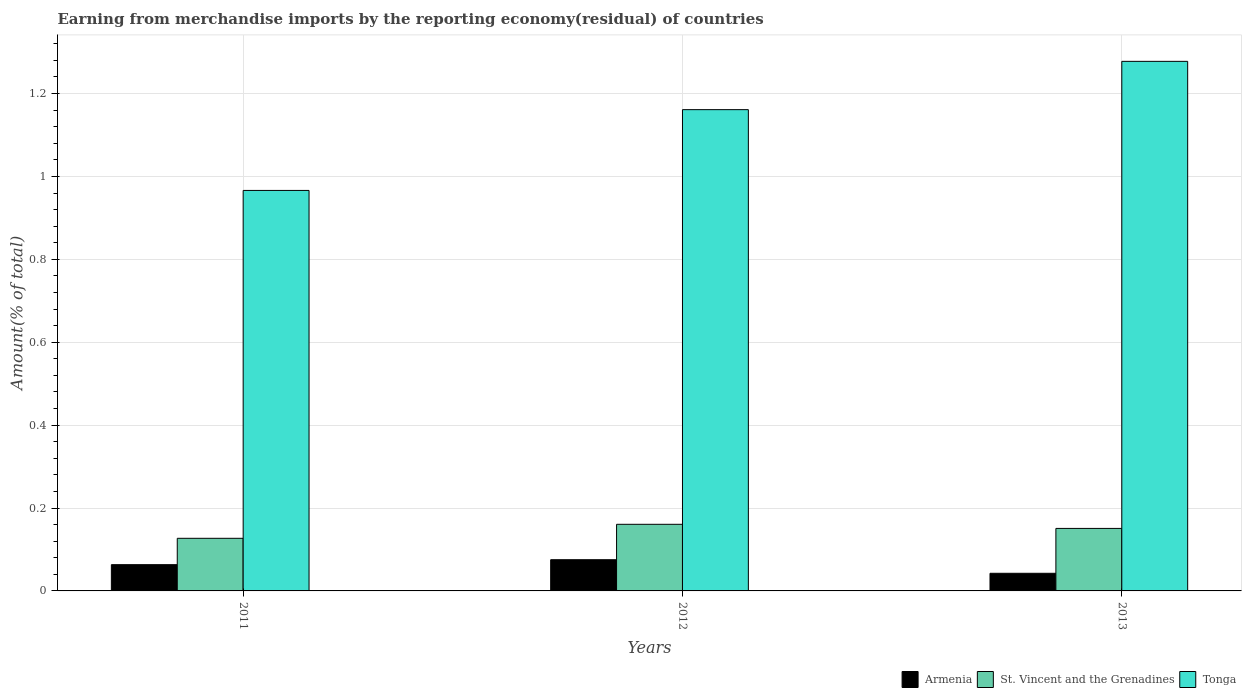How many different coloured bars are there?
Make the answer very short. 3. How many bars are there on the 1st tick from the left?
Your answer should be compact. 3. How many bars are there on the 3rd tick from the right?
Make the answer very short. 3. What is the percentage of amount earned from merchandise imports in Armenia in 2011?
Provide a short and direct response. 0.06. Across all years, what is the maximum percentage of amount earned from merchandise imports in St. Vincent and the Grenadines?
Your answer should be very brief. 0.16. Across all years, what is the minimum percentage of amount earned from merchandise imports in St. Vincent and the Grenadines?
Ensure brevity in your answer.  0.13. In which year was the percentage of amount earned from merchandise imports in Tonga minimum?
Provide a short and direct response. 2011. What is the total percentage of amount earned from merchandise imports in St. Vincent and the Grenadines in the graph?
Ensure brevity in your answer.  0.44. What is the difference between the percentage of amount earned from merchandise imports in Armenia in 2011 and that in 2013?
Offer a terse response. 0.02. What is the difference between the percentage of amount earned from merchandise imports in St. Vincent and the Grenadines in 2011 and the percentage of amount earned from merchandise imports in Tonga in 2012?
Give a very brief answer. -1.03. What is the average percentage of amount earned from merchandise imports in St. Vincent and the Grenadines per year?
Your answer should be very brief. 0.15. In the year 2013, what is the difference between the percentage of amount earned from merchandise imports in St. Vincent and the Grenadines and percentage of amount earned from merchandise imports in Armenia?
Provide a short and direct response. 0.11. What is the ratio of the percentage of amount earned from merchandise imports in Tonga in 2012 to that in 2013?
Offer a terse response. 0.91. What is the difference between the highest and the second highest percentage of amount earned from merchandise imports in Armenia?
Provide a short and direct response. 0.01. What is the difference between the highest and the lowest percentage of amount earned from merchandise imports in Armenia?
Keep it short and to the point. 0.03. Is the sum of the percentage of amount earned from merchandise imports in St. Vincent and the Grenadines in 2011 and 2012 greater than the maximum percentage of amount earned from merchandise imports in Tonga across all years?
Your response must be concise. No. What does the 3rd bar from the left in 2011 represents?
Your answer should be compact. Tonga. What does the 1st bar from the right in 2011 represents?
Provide a short and direct response. Tonga. How many years are there in the graph?
Your response must be concise. 3. What is the difference between two consecutive major ticks on the Y-axis?
Ensure brevity in your answer.  0.2. Are the values on the major ticks of Y-axis written in scientific E-notation?
Ensure brevity in your answer.  No. Does the graph contain grids?
Make the answer very short. Yes. How many legend labels are there?
Give a very brief answer. 3. How are the legend labels stacked?
Ensure brevity in your answer.  Horizontal. What is the title of the graph?
Give a very brief answer. Earning from merchandise imports by the reporting economy(residual) of countries. Does "Liberia" appear as one of the legend labels in the graph?
Ensure brevity in your answer.  No. What is the label or title of the X-axis?
Your answer should be compact. Years. What is the label or title of the Y-axis?
Offer a very short reply. Amount(% of total). What is the Amount(% of total) in Armenia in 2011?
Make the answer very short. 0.06. What is the Amount(% of total) in St. Vincent and the Grenadines in 2011?
Give a very brief answer. 0.13. What is the Amount(% of total) of Tonga in 2011?
Offer a very short reply. 0.97. What is the Amount(% of total) in Armenia in 2012?
Your answer should be very brief. 0.08. What is the Amount(% of total) of St. Vincent and the Grenadines in 2012?
Your answer should be compact. 0.16. What is the Amount(% of total) in Tonga in 2012?
Ensure brevity in your answer.  1.16. What is the Amount(% of total) in Armenia in 2013?
Keep it short and to the point. 0.04. What is the Amount(% of total) of St. Vincent and the Grenadines in 2013?
Give a very brief answer. 0.15. What is the Amount(% of total) in Tonga in 2013?
Make the answer very short. 1.28. Across all years, what is the maximum Amount(% of total) in Armenia?
Your answer should be compact. 0.08. Across all years, what is the maximum Amount(% of total) in St. Vincent and the Grenadines?
Provide a succinct answer. 0.16. Across all years, what is the maximum Amount(% of total) of Tonga?
Your answer should be compact. 1.28. Across all years, what is the minimum Amount(% of total) of Armenia?
Your answer should be very brief. 0.04. Across all years, what is the minimum Amount(% of total) of St. Vincent and the Grenadines?
Ensure brevity in your answer.  0.13. Across all years, what is the minimum Amount(% of total) in Tonga?
Give a very brief answer. 0.97. What is the total Amount(% of total) in Armenia in the graph?
Your response must be concise. 0.18. What is the total Amount(% of total) of St. Vincent and the Grenadines in the graph?
Ensure brevity in your answer.  0.44. What is the total Amount(% of total) in Tonga in the graph?
Your answer should be very brief. 3.4. What is the difference between the Amount(% of total) in Armenia in 2011 and that in 2012?
Offer a terse response. -0.01. What is the difference between the Amount(% of total) of St. Vincent and the Grenadines in 2011 and that in 2012?
Provide a succinct answer. -0.03. What is the difference between the Amount(% of total) in Tonga in 2011 and that in 2012?
Offer a very short reply. -0.19. What is the difference between the Amount(% of total) in Armenia in 2011 and that in 2013?
Your answer should be compact. 0.02. What is the difference between the Amount(% of total) in St. Vincent and the Grenadines in 2011 and that in 2013?
Provide a succinct answer. -0.02. What is the difference between the Amount(% of total) in Tonga in 2011 and that in 2013?
Offer a very short reply. -0.31. What is the difference between the Amount(% of total) of Armenia in 2012 and that in 2013?
Keep it short and to the point. 0.03. What is the difference between the Amount(% of total) in St. Vincent and the Grenadines in 2012 and that in 2013?
Provide a succinct answer. 0.01. What is the difference between the Amount(% of total) in Tonga in 2012 and that in 2013?
Give a very brief answer. -0.12. What is the difference between the Amount(% of total) in Armenia in 2011 and the Amount(% of total) in St. Vincent and the Grenadines in 2012?
Give a very brief answer. -0.1. What is the difference between the Amount(% of total) in Armenia in 2011 and the Amount(% of total) in Tonga in 2012?
Your answer should be compact. -1.1. What is the difference between the Amount(% of total) in St. Vincent and the Grenadines in 2011 and the Amount(% of total) in Tonga in 2012?
Provide a succinct answer. -1.03. What is the difference between the Amount(% of total) in Armenia in 2011 and the Amount(% of total) in St. Vincent and the Grenadines in 2013?
Offer a terse response. -0.09. What is the difference between the Amount(% of total) of Armenia in 2011 and the Amount(% of total) of Tonga in 2013?
Offer a terse response. -1.21. What is the difference between the Amount(% of total) of St. Vincent and the Grenadines in 2011 and the Amount(% of total) of Tonga in 2013?
Offer a very short reply. -1.15. What is the difference between the Amount(% of total) of Armenia in 2012 and the Amount(% of total) of St. Vincent and the Grenadines in 2013?
Provide a succinct answer. -0.08. What is the difference between the Amount(% of total) of Armenia in 2012 and the Amount(% of total) of Tonga in 2013?
Your answer should be compact. -1.2. What is the difference between the Amount(% of total) of St. Vincent and the Grenadines in 2012 and the Amount(% of total) of Tonga in 2013?
Keep it short and to the point. -1.12. What is the average Amount(% of total) of Armenia per year?
Give a very brief answer. 0.06. What is the average Amount(% of total) in St. Vincent and the Grenadines per year?
Your answer should be very brief. 0.15. What is the average Amount(% of total) in Tonga per year?
Give a very brief answer. 1.14. In the year 2011, what is the difference between the Amount(% of total) in Armenia and Amount(% of total) in St. Vincent and the Grenadines?
Provide a succinct answer. -0.06. In the year 2011, what is the difference between the Amount(% of total) in Armenia and Amount(% of total) in Tonga?
Offer a terse response. -0.9. In the year 2011, what is the difference between the Amount(% of total) in St. Vincent and the Grenadines and Amount(% of total) in Tonga?
Your response must be concise. -0.84. In the year 2012, what is the difference between the Amount(% of total) of Armenia and Amount(% of total) of St. Vincent and the Grenadines?
Offer a terse response. -0.09. In the year 2012, what is the difference between the Amount(% of total) of Armenia and Amount(% of total) of Tonga?
Your answer should be compact. -1.09. In the year 2012, what is the difference between the Amount(% of total) in St. Vincent and the Grenadines and Amount(% of total) in Tonga?
Give a very brief answer. -1. In the year 2013, what is the difference between the Amount(% of total) in Armenia and Amount(% of total) in St. Vincent and the Grenadines?
Your answer should be very brief. -0.11. In the year 2013, what is the difference between the Amount(% of total) of Armenia and Amount(% of total) of Tonga?
Give a very brief answer. -1.24. In the year 2013, what is the difference between the Amount(% of total) in St. Vincent and the Grenadines and Amount(% of total) in Tonga?
Provide a succinct answer. -1.13. What is the ratio of the Amount(% of total) in Armenia in 2011 to that in 2012?
Offer a terse response. 0.84. What is the ratio of the Amount(% of total) of St. Vincent and the Grenadines in 2011 to that in 2012?
Offer a very short reply. 0.79. What is the ratio of the Amount(% of total) of Tonga in 2011 to that in 2012?
Your answer should be very brief. 0.83. What is the ratio of the Amount(% of total) of Armenia in 2011 to that in 2013?
Provide a succinct answer. 1.49. What is the ratio of the Amount(% of total) in St. Vincent and the Grenadines in 2011 to that in 2013?
Offer a terse response. 0.84. What is the ratio of the Amount(% of total) of Tonga in 2011 to that in 2013?
Make the answer very short. 0.76. What is the ratio of the Amount(% of total) of Armenia in 2012 to that in 2013?
Offer a very short reply. 1.77. What is the ratio of the Amount(% of total) in St. Vincent and the Grenadines in 2012 to that in 2013?
Give a very brief answer. 1.07. What is the ratio of the Amount(% of total) in Tonga in 2012 to that in 2013?
Keep it short and to the point. 0.91. What is the difference between the highest and the second highest Amount(% of total) in Armenia?
Your response must be concise. 0.01. What is the difference between the highest and the second highest Amount(% of total) in St. Vincent and the Grenadines?
Offer a very short reply. 0.01. What is the difference between the highest and the second highest Amount(% of total) in Tonga?
Your answer should be compact. 0.12. What is the difference between the highest and the lowest Amount(% of total) of Armenia?
Offer a terse response. 0.03. What is the difference between the highest and the lowest Amount(% of total) of St. Vincent and the Grenadines?
Provide a short and direct response. 0.03. What is the difference between the highest and the lowest Amount(% of total) of Tonga?
Your answer should be very brief. 0.31. 